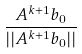<formula> <loc_0><loc_0><loc_500><loc_500>\frac { A ^ { k + 1 } b _ { 0 } } { | | A ^ { k + 1 } b _ { 0 } | | }</formula> 